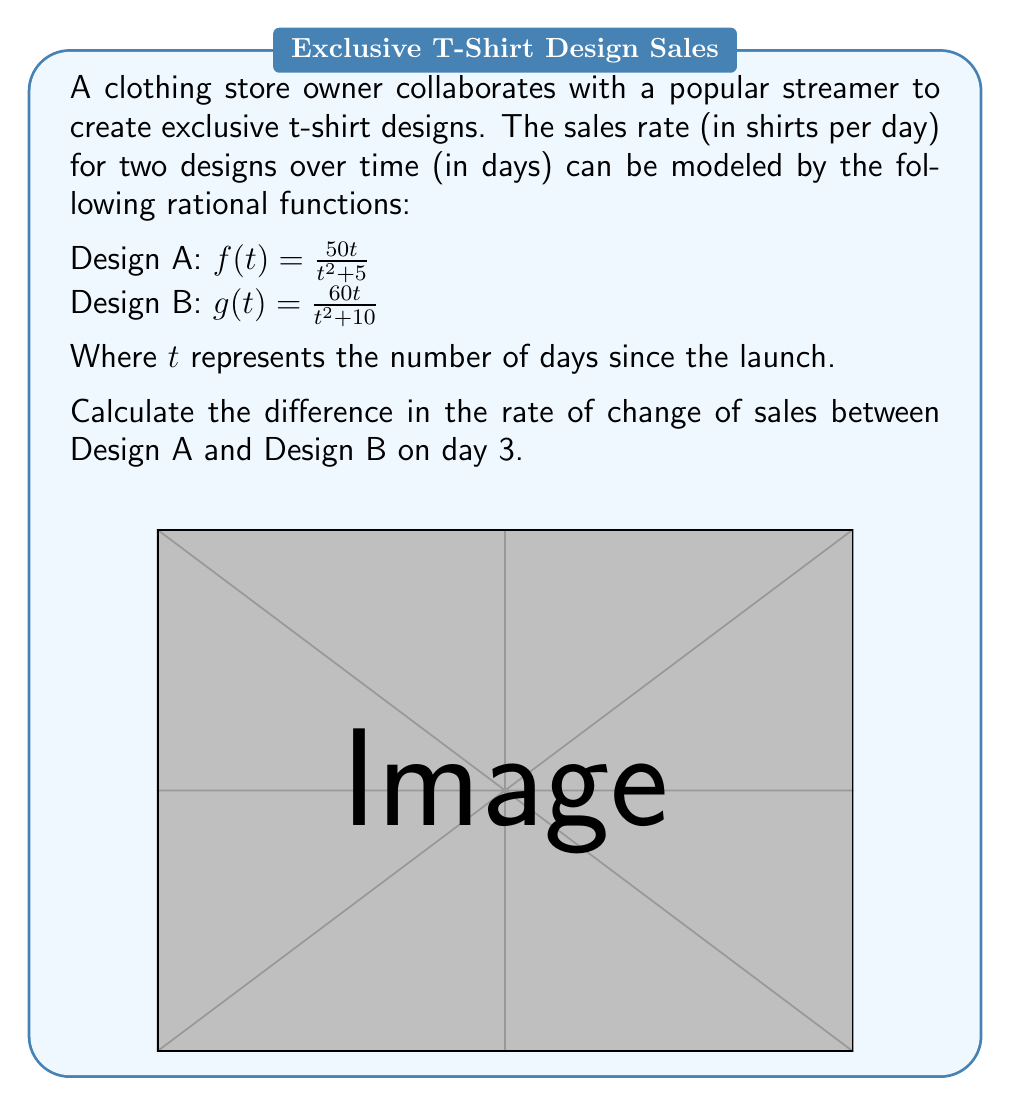Give your solution to this math problem. To solve this problem, we need to follow these steps:

1) First, we need to find the derivative of each function to get the rate of change:

   For Design A: $f(t) = \frac{50t}{t^2 + 5}$
   $f'(t) = \frac{50(t^2+5) - 50t(2t)}{(t^2+5)^2} = \frac{50(5-t^2)}{(t^2+5)^2}$

   For Design B: $g(t) = \frac{60t}{t^2 + 10}$
   $g'(t) = \frac{60(t^2+10) - 60t(2t)}{(t^2+10)^2} = \frac{60(10-t^2)}{(t^2+10)^2}$

2) Now, we need to evaluate these derivatives at $t=3$:

   For Design A: $f'(3) = \frac{50(5-3^2)}{(3^2+5)^2} = \frac{50(-4)}{14^2} = \frac{-200}{196} = -\frac{25}{49}$

   For Design B: $g'(3) = \frac{60(10-3^2)}{(3^2+10)^2} = \frac{60(1)}{19^2} = \frac{60}{361}$

3) Finally, we calculate the difference between these rates of change:

   Difference = $f'(3) - g'(3) = -\frac{25}{49} - \frac{60}{361} = -\frac{1525}{2989} + \frac{720}{2989} = -\frac{805}{2989}$
Answer: $-\frac{805}{2989}$ shirts/day² 